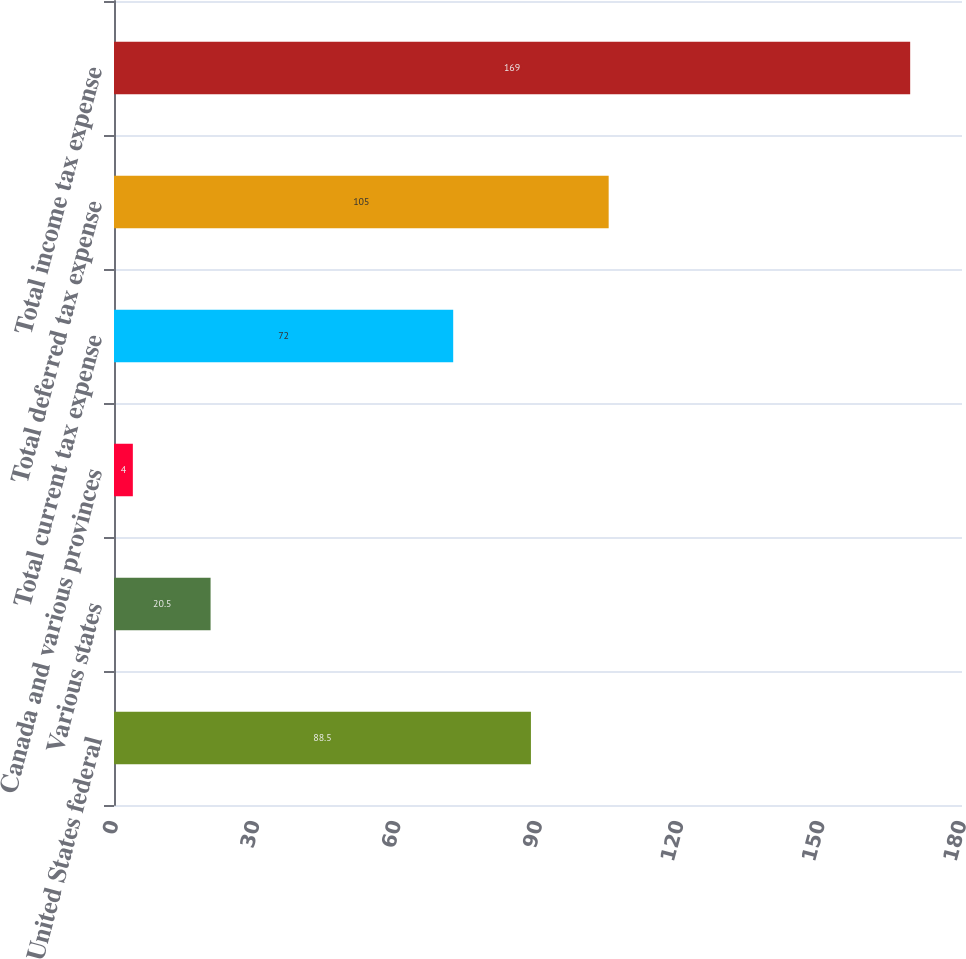Convert chart. <chart><loc_0><loc_0><loc_500><loc_500><bar_chart><fcel>United States federal<fcel>Various states<fcel>Canada and various provinces<fcel>Total current tax expense<fcel>Total deferred tax expense<fcel>Total income tax expense<nl><fcel>88.5<fcel>20.5<fcel>4<fcel>72<fcel>105<fcel>169<nl></chart> 